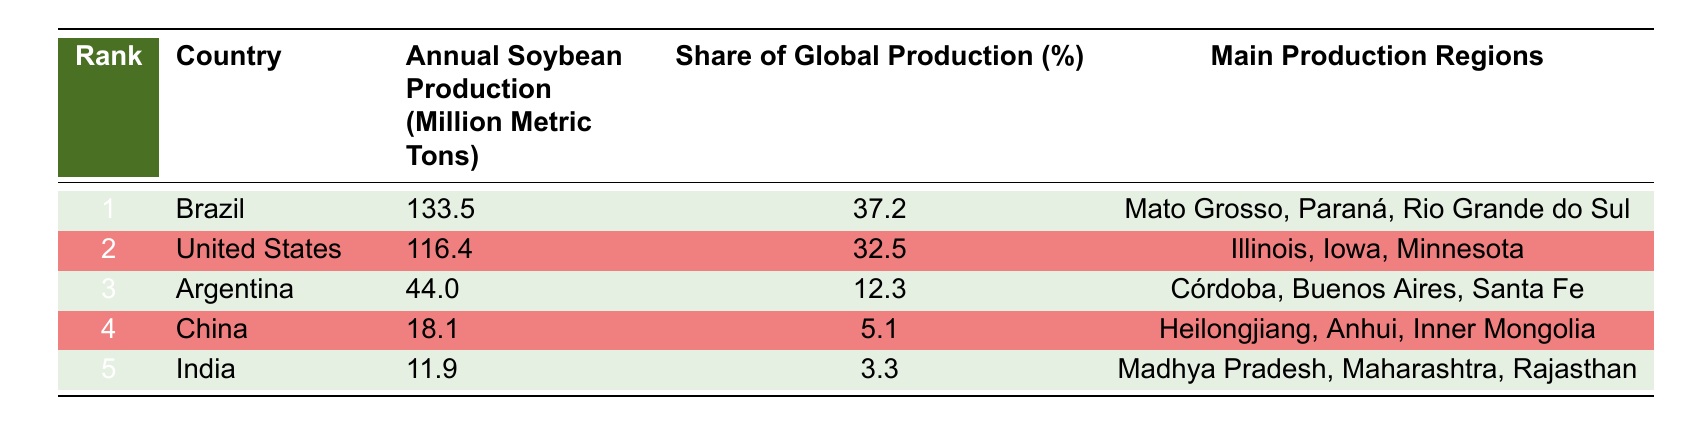What is the annual soybean production of Brazil? According to the table, Brazil's annual soybean production is directly listed under the corresponding column, which shows the value as 133.5 million metric tons.
Answer: 133.5 million metric tons Which country produces the least soybeans according to the table? The table ranks the countries based on their annual soybean production. The country ranked fifth, which produces the least soybeans, is India, with an output of 11.9 million metric tons.
Answer: India What is the total annual soybean production of the top three producing countries? To find the total production of the top three countries, add their individual productions: Brazil (133.5) + United States (116.4) + Argentina (44.0). The sum is 133.5 + 116.4 + 44.0 = 294.9 million metric tons.
Answer: 294.9 million metric tons Is China's share of global soybean production higher than that of Argentina? According to the table, China has a share of 5.1% and Argentina has a share of 12.3%. Since 5.1% is less than 12.3%, China's share is not higher than Argentina's.
Answer: No Which country contributes the highest percentage to global soybean production? The table indicates the share of global production for each country. Brazil has the highest share listed as 37.2%, thus it contributes the most to global soybean production.
Answer: Brazil 